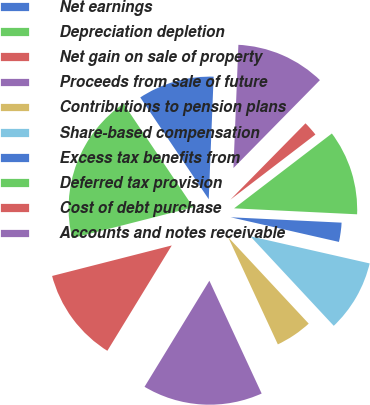Convert chart to OTSL. <chart><loc_0><loc_0><loc_500><loc_500><pie_chart><fcel>Net earnings<fcel>Depreciation depletion<fcel>Net gain on sale of property<fcel>Proceeds from sale of future<fcel>Contributions to pension plans<fcel>Share-based compensation<fcel>Excess tax benefits from<fcel>Deferred tax provision<fcel>Cost of debt purchase<fcel>Accounts and notes receivable<nl><fcel>10.06%<fcel>19.55%<fcel>12.29%<fcel>15.64%<fcel>5.03%<fcel>9.5%<fcel>2.79%<fcel>11.17%<fcel>2.23%<fcel>11.73%<nl></chart> 